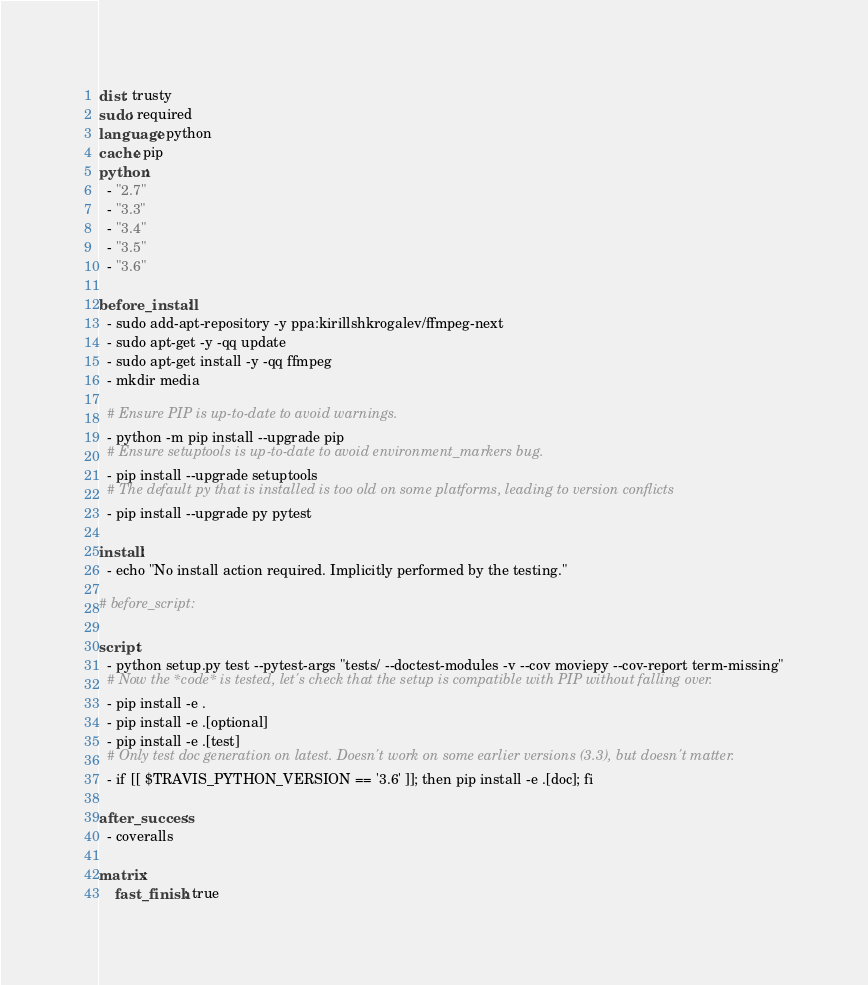Convert code to text. <code><loc_0><loc_0><loc_500><loc_500><_YAML_>dist: trusty
sudo: required
language: python
cache: pip
python:
  - "2.7"
  - "3.3"
  - "3.4"
  - "3.5"
  - "3.6"

before_install:
  - sudo add-apt-repository -y ppa:kirillshkrogalev/ffmpeg-next
  - sudo apt-get -y -qq update
  - sudo apt-get install -y -qq ffmpeg
  - mkdir media

  # Ensure PIP is up-to-date to avoid warnings.
  - python -m pip install --upgrade pip
  # Ensure setuptools is up-to-date to avoid environment_markers bug.
  - pip install --upgrade setuptools
  # The default py that is installed is too old on some platforms, leading to version conflicts
  - pip install --upgrade py pytest

install:
  - echo "No install action required. Implicitly performed by the testing."

# before_script:

script:
  - python setup.py test --pytest-args "tests/ --doctest-modules -v --cov moviepy --cov-report term-missing"
  # Now the *code* is tested, let's check that the setup is compatible with PIP without falling over.
  - pip install -e .
  - pip install -e .[optional]
  - pip install -e .[test]
  # Only test doc generation on latest. Doesn't work on some earlier versions (3.3), but doesn't matter.
  - if [[ $TRAVIS_PYTHON_VERSION == '3.6' ]]; then pip install -e .[doc]; fi

after_success:
  - coveralls

matrix:
    fast_finish: true
</code> 